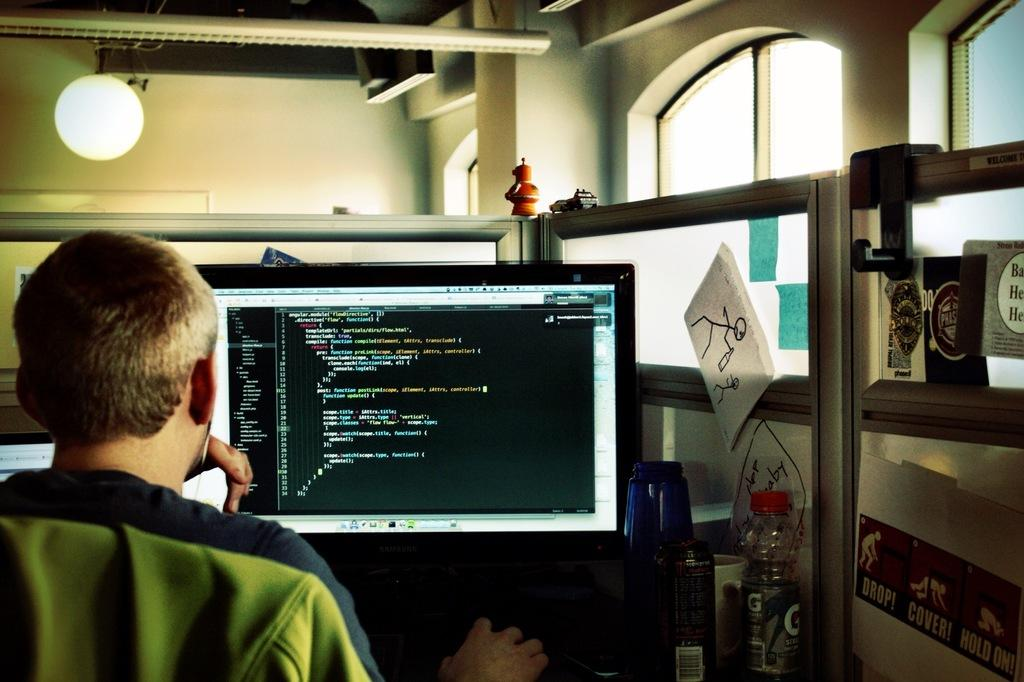What is the person in the image doing? The person is sitting in the image. What is the person facing while sitting? The person is facing a monitor. What object can be seen near the person? There is a bottle in the image. What type of material is present in the image? There is paper in the image. What can be seen providing illumination in the image? There are lights in the image. What type of lace can be seen on the person's clothing in the image? There is no lace visible on the person's clothing in the image. What is the condition of the swing in the image? There is no swing present in the image. 